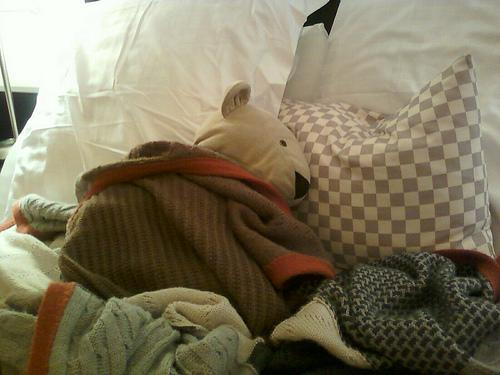Question: how many bears are in the photo?
Choices:
A. One.
B. Two.
C. Zero.
D. Three.
Answer with the letter. Answer: A Question: why is the bear covered?
Choices:
A. New born.
B. It's cold.
C. It is sick.
D. Taking a nap.
Answer with the letter. Answer: D Question: where is the bear located?
Choices:
A. On a bed.
B. In a zoo.
C. The mountains.
D. A forest.
Answer with the letter. Answer: A Question: what pattern is the pillow the bear is on?
Choices:
A. Plaid.
B. Striped.
C. Paisley.
D. Checkered.
Answer with the letter. Answer: D Question: what color are the two big pillows?
Choices:
A. Red.
B. Brown.
C. Tan.
D. White.
Answer with the letter. Answer: D 